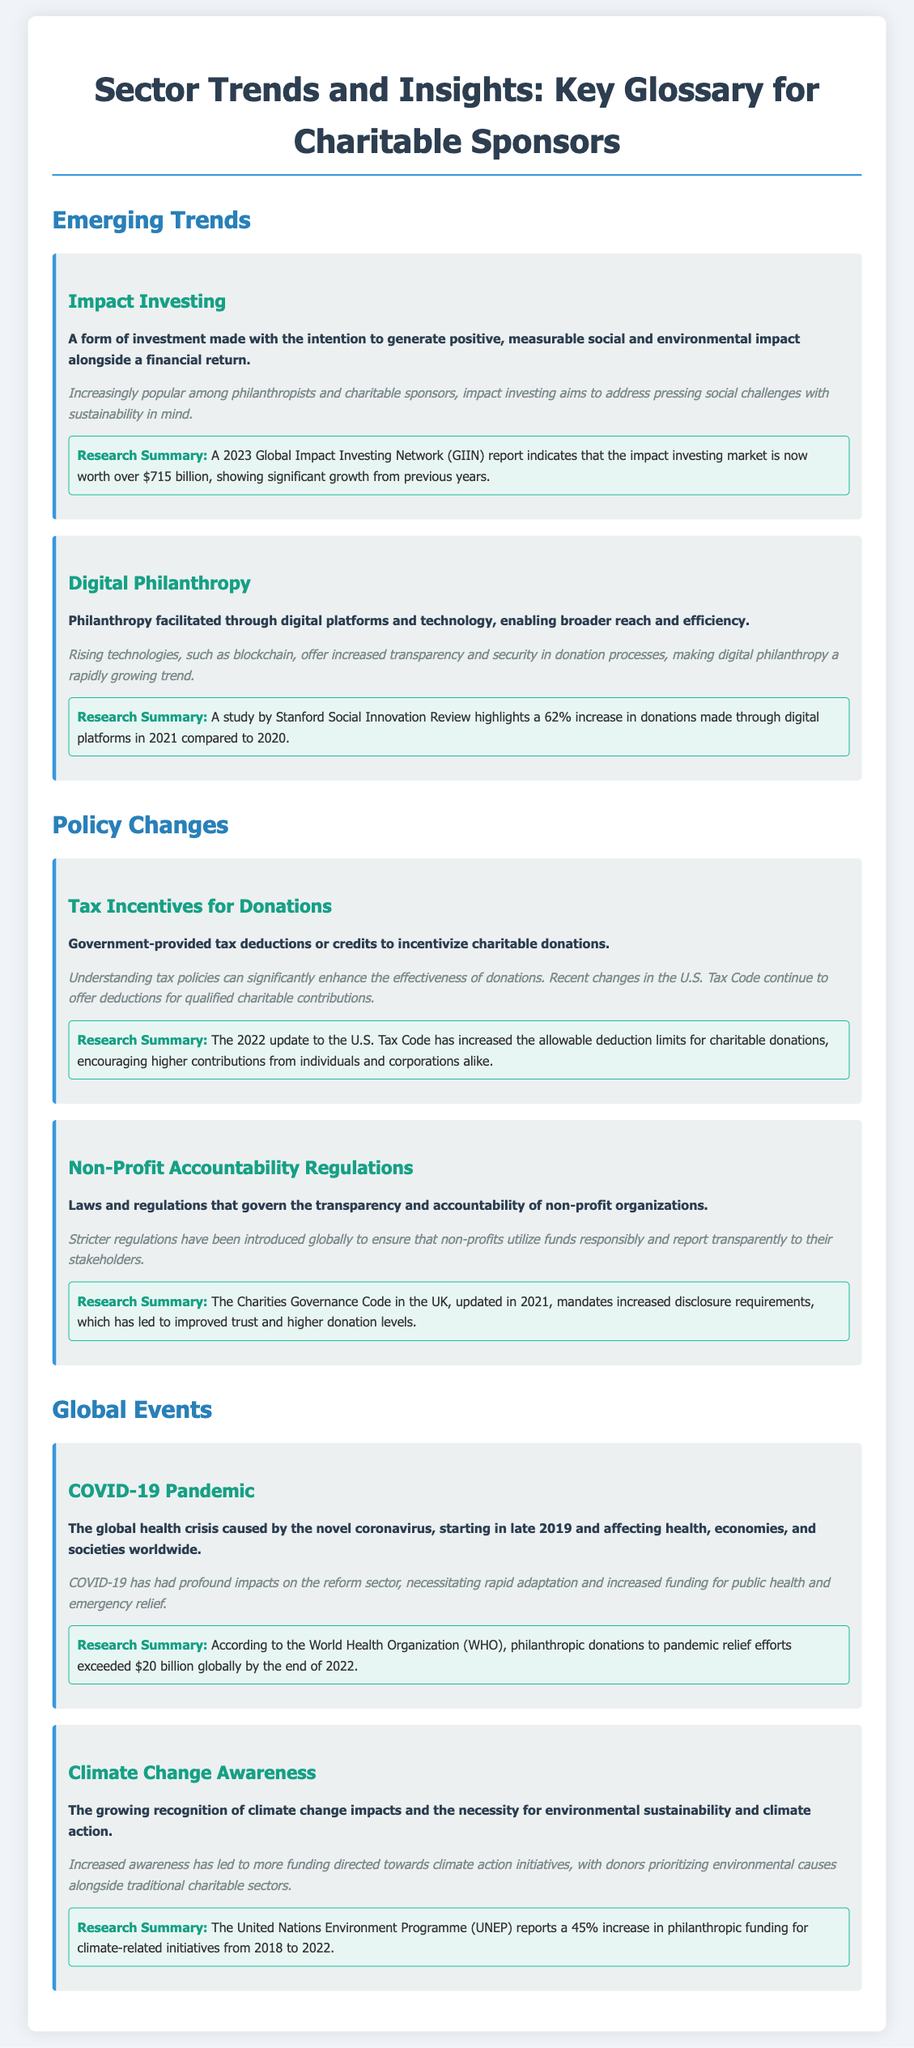What is impact investing? Impact investing is defined in the document as a form of investment made with the intention to generate positive, measurable social and environmental impact alongside a financial return.
Answer: A form of investment made with the intention to generate positive, measurable social and environmental impact alongside a financial return What was the impact of COVID-19 on philanthropic donations? The document states that philanthropic donations to pandemic relief efforts exceeded $20 billion globally by the end of 2022.
Answer: Exceeded $20 billion What is the reported worth of the impact investing market in 2023? The 2023 Global Impact Investing Network (GIIN) report indicates that the impact investing market is now worth over $715 billion.
Answer: Over $715 billion What change did the 2022 update to the U.S. Tax Code make for charitable donations? The 2022 update increased the allowable deduction limits for charitable donations.
Answer: Increased allowable deduction limits What percentage increase in donations through digital platforms was noted in 2021? The study by Stanford Social Innovation Review highlights a 62% increase in donations made through digital platforms in 2021 compared to 2020.
Answer: 62% What is one emerging trend mentioned in the document? The document lists several trends; one of them is digital philanthropy.
Answer: Digital philanthropy What do non-profit accountability regulations govern? The document defines non-profit accountability regulations as laws that govern the transparency and accountability of non-profit organizations.
Answer: Transparency and accountability What is the increase percentage in philanthropic funding for climate-related initiatives from 2018 to 2022? According to the UNEP, there was a 45% increase in philanthropic funding for climate-related initiatives from 2018 to 2022.
Answer: 45% 